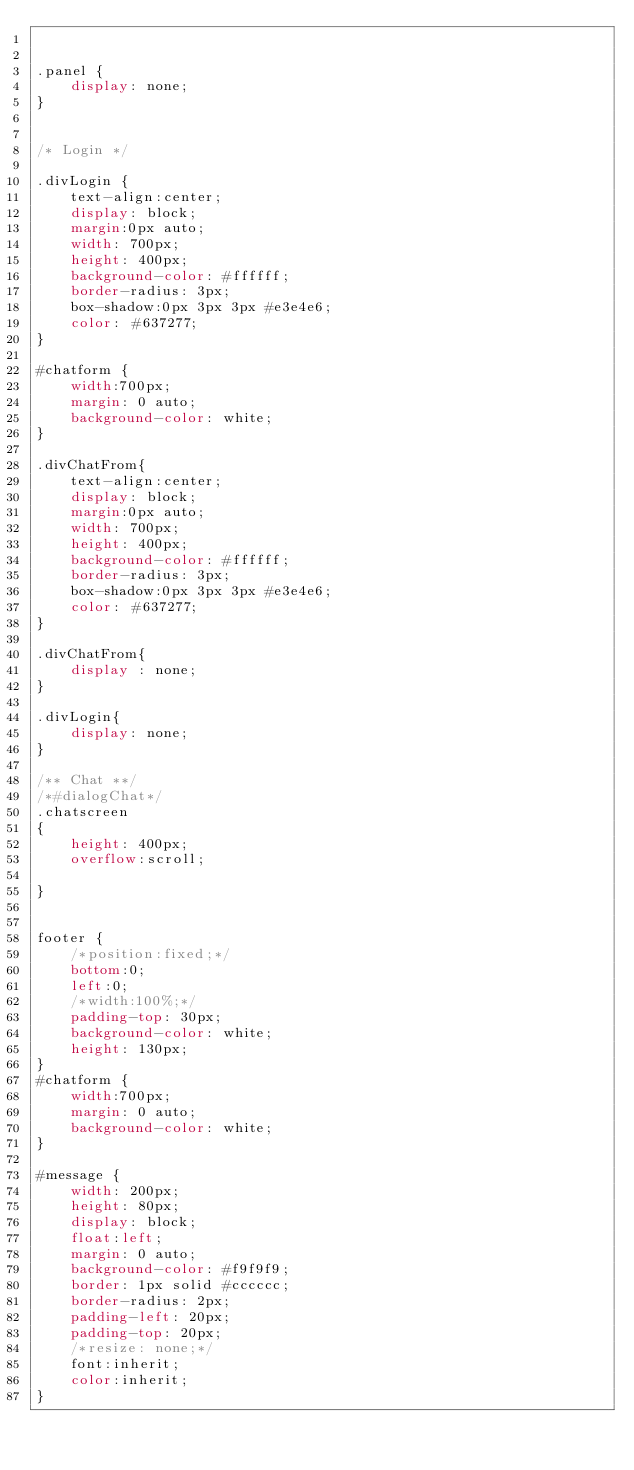Convert code to text. <code><loc_0><loc_0><loc_500><loc_500><_CSS_>

.panel {
    display: none;
}


/* Login */

.divLogin {
    text-align:center;
    display: block;
    margin:0px auto;
    width: 700px;
    height: 400px;
    background-color: #ffffff;
    border-radius: 3px;
    box-shadow:0px 3px 3px #e3e4e6;
    color: #637277;
}

#chatform {
    width:700px;
    margin: 0 auto;
    background-color: white;
}

.divChatFrom{
    text-align:center;
    display: block;
    margin:0px auto;
    width: 700px;
    height: 400px;
    background-color: #ffffff;
    border-radius: 3px;
    box-shadow:0px 3px 3px #e3e4e6;
    color: #637277;
}

.divChatFrom{
    display : none;
}

.divLogin{
    display: none;
}

/** Chat **/
/*#dialogChat*/
.chatscreen
{
    height: 400px;
    overflow:scroll;

}


footer {
    /*position:fixed;*/
    bottom:0;
    left:0;
    /*width:100%;*/
    padding-top: 30px;
    background-color: white;
    height: 130px;
}
#chatform {
    width:700px;
    margin: 0 auto;
    background-color: white;
}

#message {
    width: 200px;
    height: 80px;
    display: block;
    float:left;
    margin: 0 auto;
    background-color: #f9f9f9;
    border: 1px solid #cccccc;
    border-radius: 2px;
    padding-left: 20px;
    padding-top: 20px;
    /*resize: none;*/
    font:inherit;
    color:inherit;
}</code> 